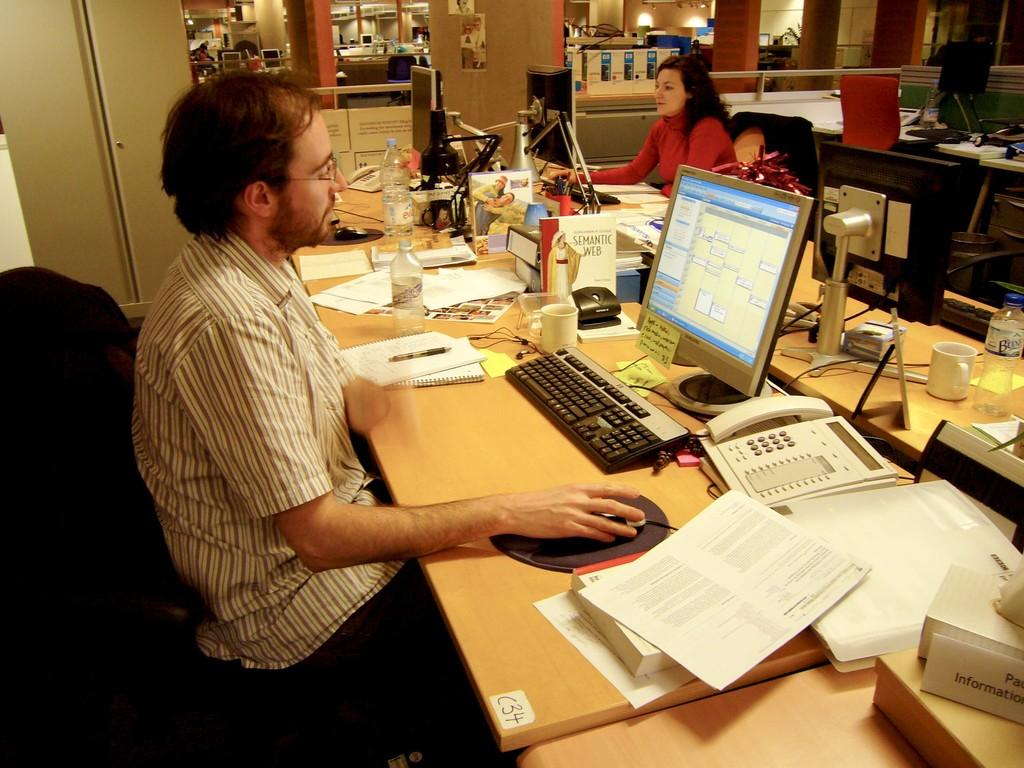<image>
Write a terse but informative summary of the picture. Man sitting at a table using a Samsung monitor. 